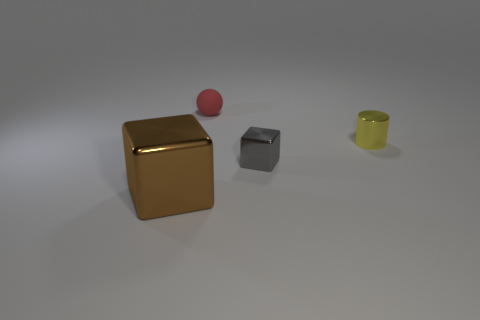Add 4 large red rubber cylinders. How many objects exist? 8 Subtract all cylinders. How many objects are left? 3 Add 1 big cyan metal cubes. How many big cyan metal cubes exist? 1 Subtract 1 red balls. How many objects are left? 3 Subtract all yellow shiny cylinders. Subtract all cubes. How many objects are left? 1 Add 1 big brown metallic blocks. How many big brown metallic blocks are left? 2 